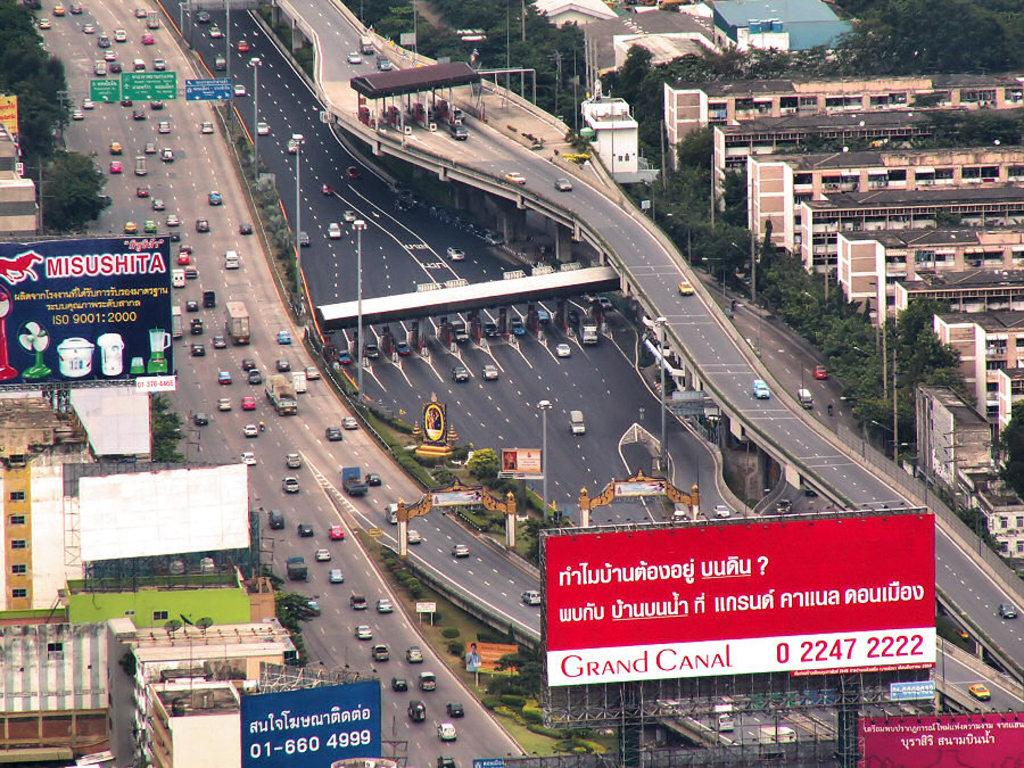<image>
Offer a succinct explanation of the picture presented. a long shot of a freeway with billboards for Grand Canal and Misushita 